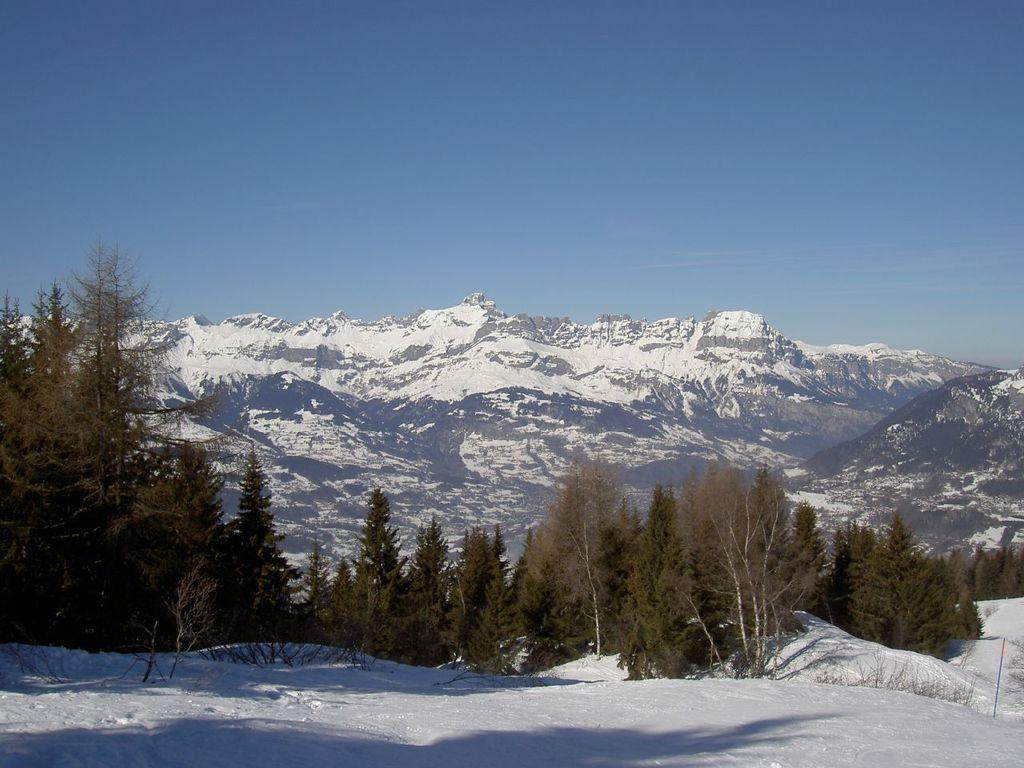What is located in the center of the image? There are trees in the center of the image. What is present at the bottom of the image? There is snow at the bottom of the image. What can be seen in the background of the image? There are mountains in the background of the image. What is visible at the top of the image? The sky is visible at the top of the image. Where is the lumber being stored in the image? There is no lumber present in the image. What type of poison can be seen in the image? There is no poison present in the image. 